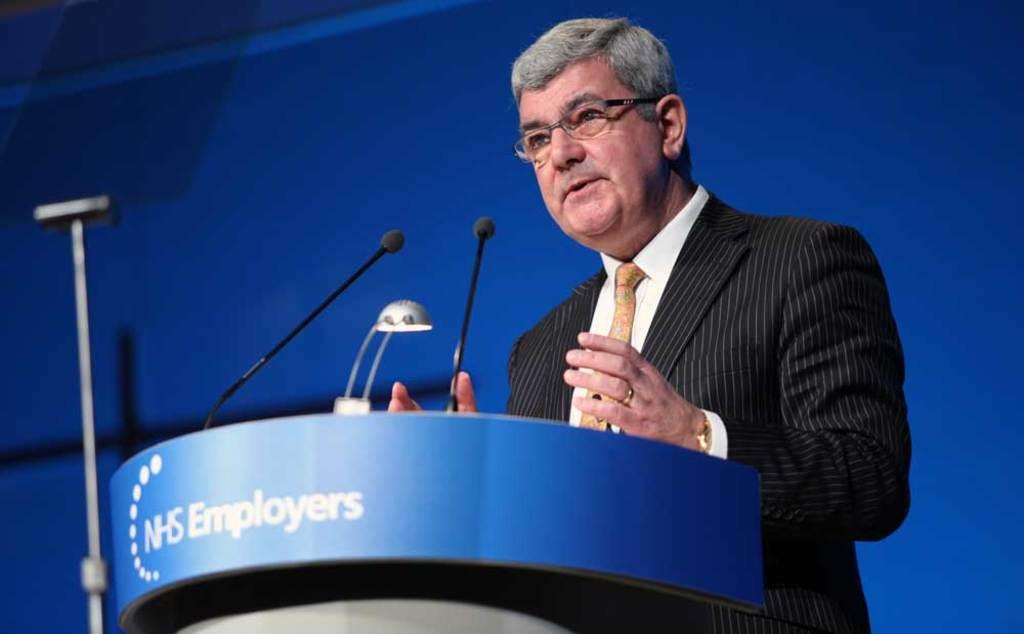What is the man in the image doing? The man is standing at the podium. What is on the podium with the man? There is a light and two microphones on the podium. What can be seen in the background of the image? There is a stand and a wall in the background. What type of trail can be seen in the image? There is no trail present in the image. How much milk is in the bucket in the image? There is no bucket or milk present in the image. 